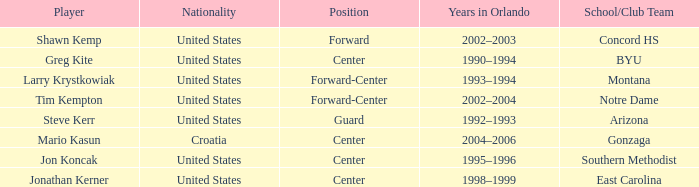What years in Orlando have the United States as the nationality, with concord hs as the school/club team? 2002–2003. 